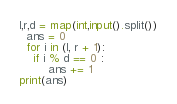Convert code to text. <code><loc_0><loc_0><loc_500><loc_500><_Python_>l,r,d = map(int,input().split())
  ans = 0
  for i in (l, r + 1):
	if i % d == 0 :
		ans += 1
print(ans)
</code> 